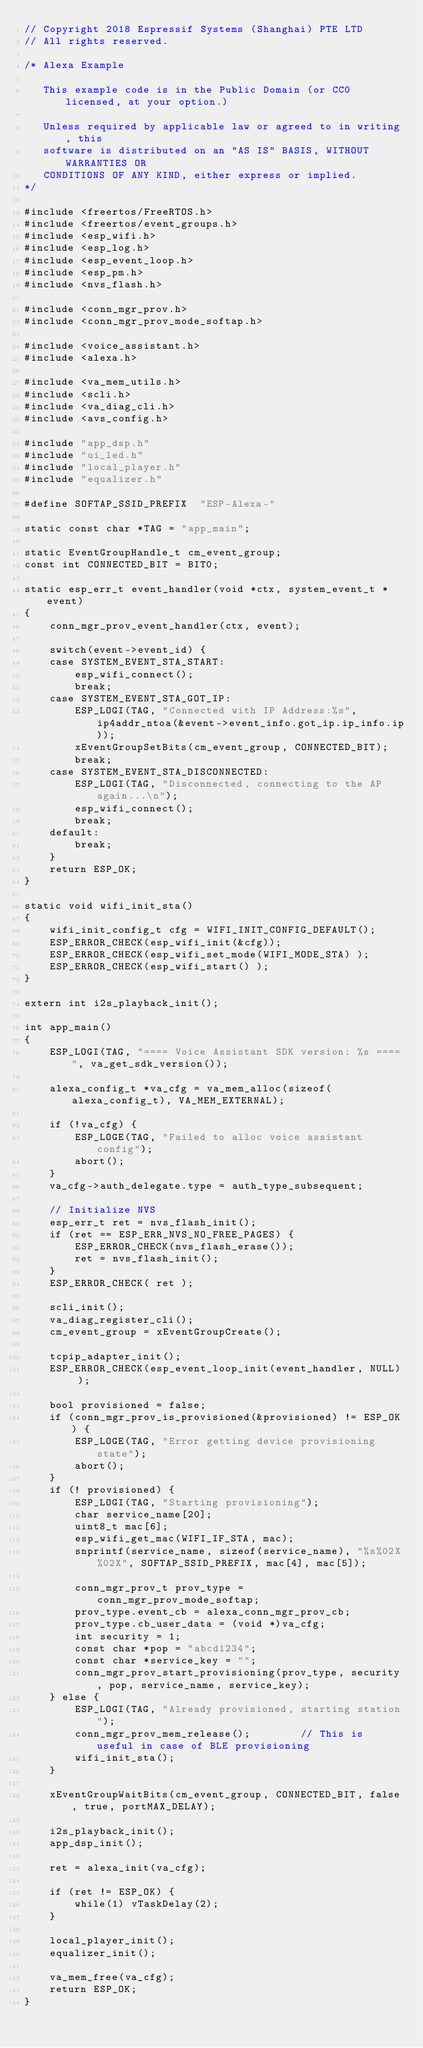<code> <loc_0><loc_0><loc_500><loc_500><_C_>// Copyright 2018 Espressif Systems (Shanghai) PTE LTD
// All rights reserved.

/* Alexa Example

   This example code is in the Public Domain (or CC0 licensed, at your option.)

   Unless required by applicable law or agreed to in writing, this
   software is distributed on an "AS IS" BASIS, WITHOUT WARRANTIES OR
   CONDITIONS OF ANY KIND, either express or implied.
*/

#include <freertos/FreeRTOS.h>
#include <freertos/event_groups.h>
#include <esp_wifi.h>
#include <esp_log.h>
#include <esp_event_loop.h>
#include <esp_pm.h>
#include <nvs_flash.h>

#include <conn_mgr_prov.h>
#include <conn_mgr_prov_mode_softap.h>

#include <voice_assistant.h>
#include <alexa.h>

#include <va_mem_utils.h>
#include <scli.h>
#include <va_diag_cli.h>
#include <avs_config.h>

#include "app_dsp.h"
#include "ui_led.h"
#include "local_player.h"
#include "equalizer.h"

#define SOFTAP_SSID_PREFIX  "ESP-Alexa-"

static const char *TAG = "app_main";

static EventGroupHandle_t cm_event_group;
const int CONNECTED_BIT = BIT0;

static esp_err_t event_handler(void *ctx, system_event_t *event)
{
    conn_mgr_prov_event_handler(ctx, event);

    switch(event->event_id) {
    case SYSTEM_EVENT_STA_START:
        esp_wifi_connect();
        break;
    case SYSTEM_EVENT_STA_GOT_IP:
        ESP_LOGI(TAG, "Connected with IP Address:%s", ip4addr_ntoa(&event->event_info.got_ip.ip_info.ip));
        xEventGroupSetBits(cm_event_group, CONNECTED_BIT);
        break;
    case SYSTEM_EVENT_STA_DISCONNECTED:
        ESP_LOGI(TAG, "Disconnected, connecting to the AP again...\n");
        esp_wifi_connect();
        break;
    default:
        break;
    }
    return ESP_OK;
}

static void wifi_init_sta()
{
    wifi_init_config_t cfg = WIFI_INIT_CONFIG_DEFAULT();
    ESP_ERROR_CHECK(esp_wifi_init(&cfg));
    ESP_ERROR_CHECK(esp_wifi_set_mode(WIFI_MODE_STA) );
    ESP_ERROR_CHECK(esp_wifi_start() );
}

extern int i2s_playback_init();

int app_main()
{
    ESP_LOGI(TAG, "==== Voice Assistant SDK version: %s ====", va_get_sdk_version());

    alexa_config_t *va_cfg = va_mem_alloc(sizeof(alexa_config_t), VA_MEM_EXTERNAL);

    if (!va_cfg) {
        ESP_LOGE(TAG, "Failed to alloc voice assistant config");
        abort();
    }
    va_cfg->auth_delegate.type = auth_type_subsequent;

    // Initialize NVS
    esp_err_t ret = nvs_flash_init();
    if (ret == ESP_ERR_NVS_NO_FREE_PAGES) {
        ESP_ERROR_CHECK(nvs_flash_erase());
        ret = nvs_flash_init();
    }
    ESP_ERROR_CHECK( ret );

    scli_init();
    va_diag_register_cli();
    cm_event_group = xEventGroupCreate();

    tcpip_adapter_init();
    ESP_ERROR_CHECK(esp_event_loop_init(event_handler, NULL) );

    bool provisioned = false;
    if (conn_mgr_prov_is_provisioned(&provisioned) != ESP_OK) {
        ESP_LOGE(TAG, "Error getting device provisioning state");
        abort();
    }
    if (! provisioned) {
        ESP_LOGI(TAG, "Starting provisioning");
        char service_name[20];
        uint8_t mac[6];
        esp_wifi_get_mac(WIFI_IF_STA, mac);
        snprintf(service_name, sizeof(service_name), "%s%02X%02X", SOFTAP_SSID_PREFIX, mac[4], mac[5]);

        conn_mgr_prov_t prov_type = conn_mgr_prov_mode_softap;
        prov_type.event_cb = alexa_conn_mgr_prov_cb;
        prov_type.cb_user_data = (void *)va_cfg;
        int security = 1;
        const char *pop = "abcd1234";
        const char *service_key = "";
        conn_mgr_prov_start_provisioning(prov_type, security, pop, service_name, service_key);
    } else {
        ESP_LOGI(TAG, "Already provisioned, starting station");
        conn_mgr_prov_mem_release();        // This is useful in case of BLE provisioning
        wifi_init_sta();
    }

    xEventGroupWaitBits(cm_event_group, CONNECTED_BIT, false, true, portMAX_DELAY);

    i2s_playback_init();
    app_dsp_init();

    ret = alexa_init(va_cfg);

    if (ret != ESP_OK) {
        while(1) vTaskDelay(2);
    }
    
    local_player_init();
    equalizer_init();

    va_mem_free(va_cfg);
    return ESP_OK;
}
</code> 